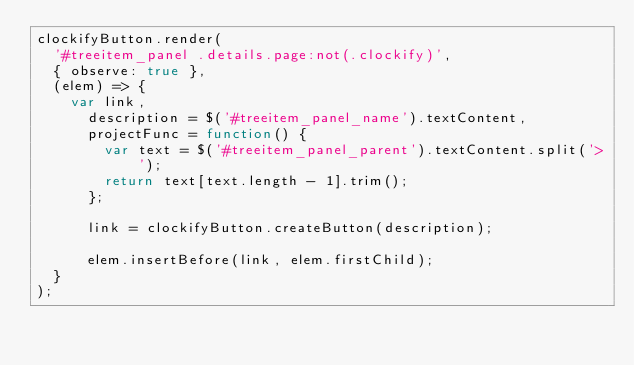<code> <loc_0><loc_0><loc_500><loc_500><_JavaScript_>clockifyButton.render(
  '#treeitem_panel .details.page:not(.clockify)',
  { observe: true },
  (elem) => {
    var link,
      description = $('#treeitem_panel_name').textContent,
      projectFunc = function() {
        var text = $('#treeitem_panel_parent').textContent.split('>');
        return text[text.length - 1].trim();
      };

      link = clockifyButton.createButton(description);

      elem.insertBefore(link, elem.firstChild);
  }
);
</code> 